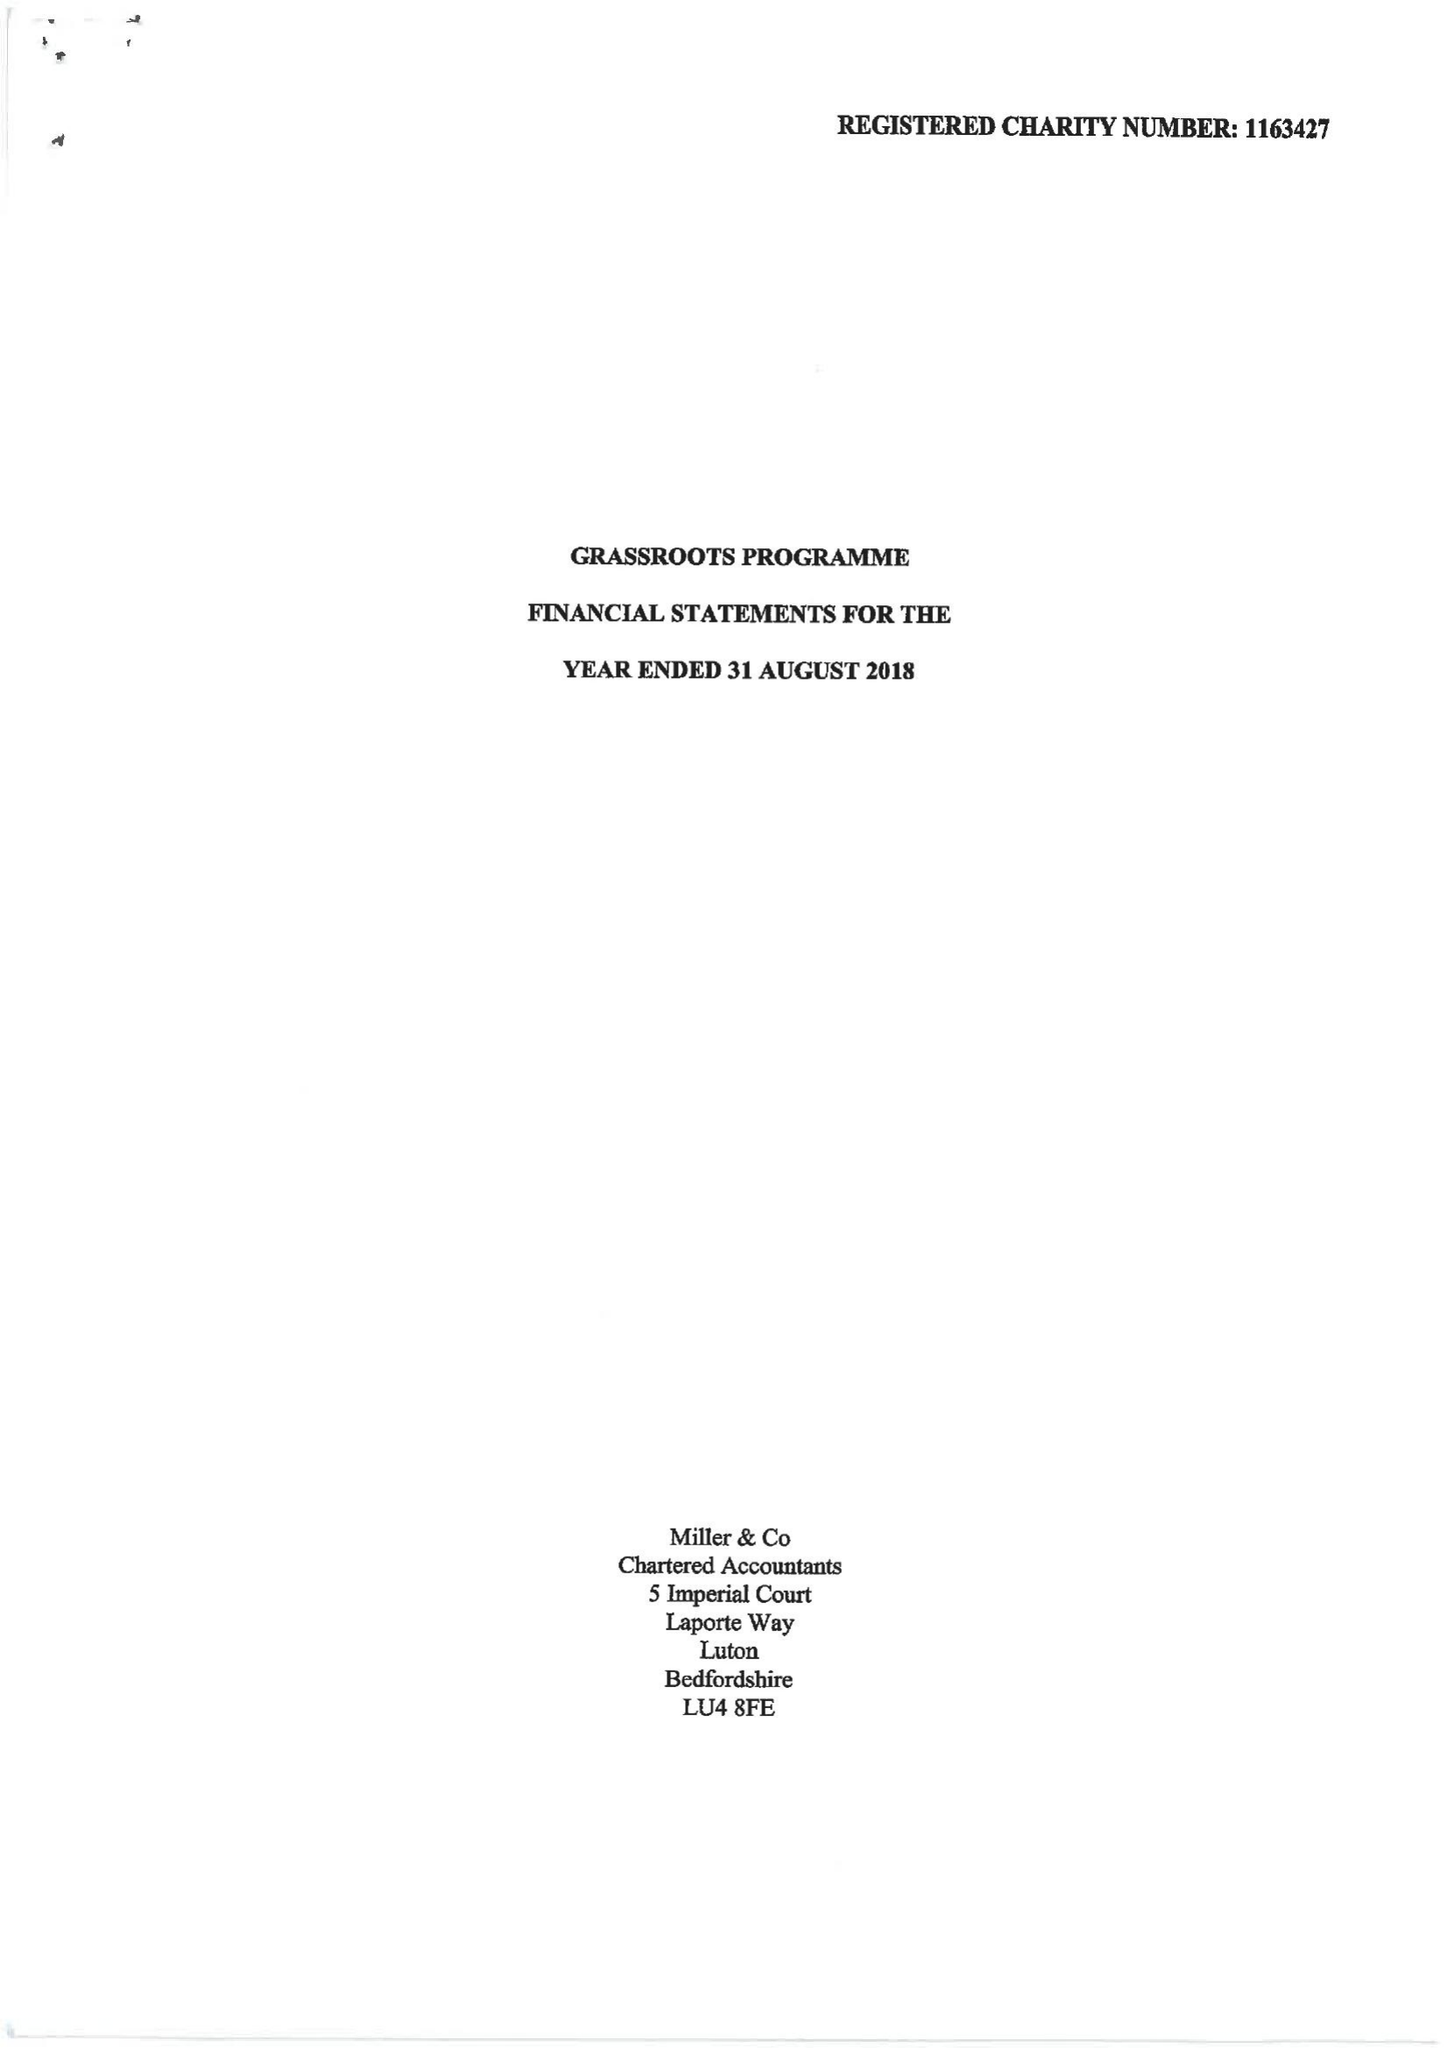What is the value for the charity_number?
Answer the question using a single word or phrase. 1163427 